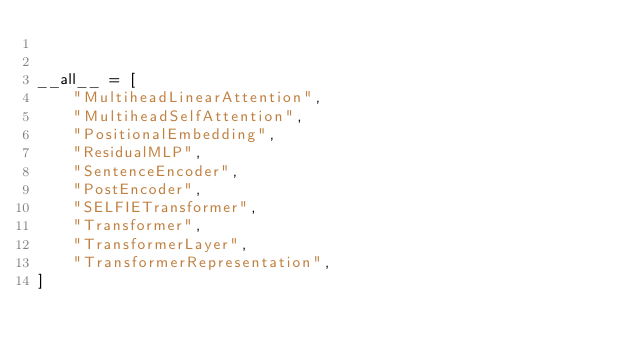Convert code to text. <code><loc_0><loc_0><loc_500><loc_500><_Python_>

__all__ = [
    "MultiheadLinearAttention",
    "MultiheadSelfAttention",
    "PositionalEmbedding",
    "ResidualMLP",
    "SentenceEncoder",
    "PostEncoder",
    "SELFIETransformer",
    "Transformer",
    "TransformerLayer",
    "TransformerRepresentation",
]
</code> 